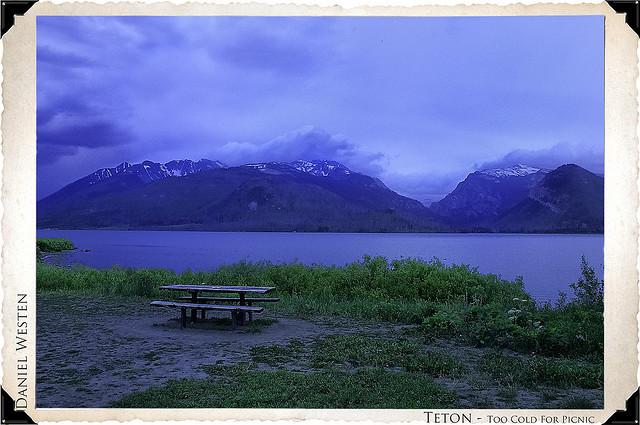Is it a sunny day?
Give a very brief answer. No. According to the card, what is it too cold for?
Quick response, please. Picnic. Is this a painting?
Concise answer only. No. Is this picture old?
Short answer required. No. What body of water is this by?
Keep it brief. Lake. Is that smoke or fog in the background?
Short answer required. Fog. What number of mountains are in the distance?
Keep it brief. 4. Is there any wind blowing?
Keep it brief. No. Is it cold here?
Keep it brief. Yes. 